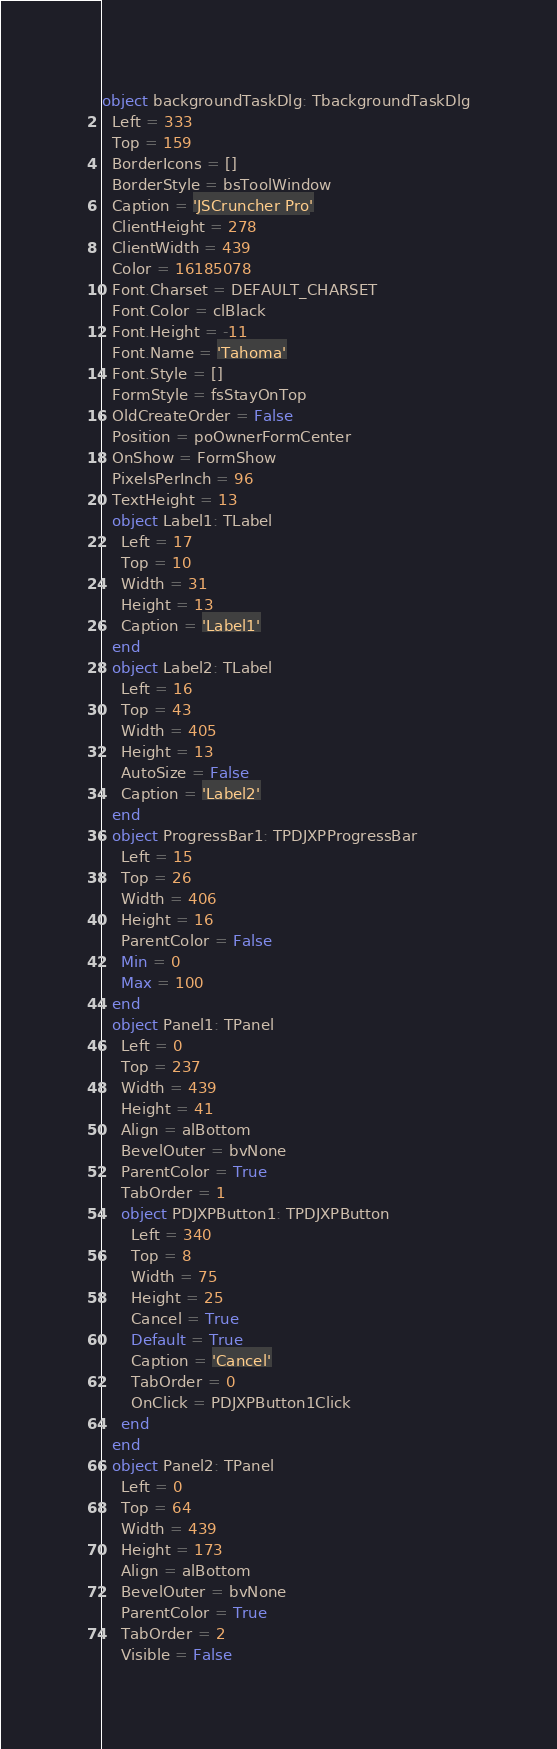<code> <loc_0><loc_0><loc_500><loc_500><_Pascal_>object backgroundTaskDlg: TbackgroundTaskDlg
  Left = 333
  Top = 159
  BorderIcons = []
  BorderStyle = bsToolWindow
  Caption = 'JSCruncher Pro'
  ClientHeight = 278
  ClientWidth = 439
  Color = 16185078
  Font.Charset = DEFAULT_CHARSET
  Font.Color = clBlack
  Font.Height = -11
  Font.Name = 'Tahoma'
  Font.Style = []
  FormStyle = fsStayOnTop
  OldCreateOrder = False
  Position = poOwnerFormCenter
  OnShow = FormShow
  PixelsPerInch = 96
  TextHeight = 13
  object Label1: TLabel
    Left = 17
    Top = 10
    Width = 31
    Height = 13
    Caption = 'Label1'
  end
  object Label2: TLabel
    Left = 16
    Top = 43
    Width = 405
    Height = 13
    AutoSize = False
    Caption = 'Label2'
  end
  object ProgressBar1: TPDJXPProgressBar
    Left = 15
    Top = 26
    Width = 406
    Height = 16
    ParentColor = False
    Min = 0
    Max = 100
  end
  object Panel1: TPanel
    Left = 0
    Top = 237
    Width = 439
    Height = 41
    Align = alBottom
    BevelOuter = bvNone
    ParentColor = True
    TabOrder = 1
    object PDJXPButton1: TPDJXPButton
      Left = 340
      Top = 8
      Width = 75
      Height = 25
      Cancel = True
      Default = True
      Caption = 'Cancel'
      TabOrder = 0
      OnClick = PDJXPButton1Click
    end
  end
  object Panel2: TPanel
    Left = 0
    Top = 64
    Width = 439
    Height = 173
    Align = alBottom
    BevelOuter = bvNone
    ParentColor = True
    TabOrder = 2
    Visible = False</code> 